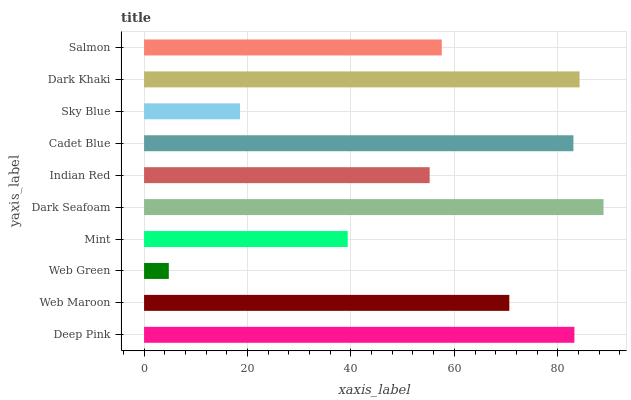Is Web Green the minimum?
Answer yes or no. Yes. Is Dark Seafoam the maximum?
Answer yes or no. Yes. Is Web Maroon the minimum?
Answer yes or no. No. Is Web Maroon the maximum?
Answer yes or no. No. Is Deep Pink greater than Web Maroon?
Answer yes or no. Yes. Is Web Maroon less than Deep Pink?
Answer yes or no. Yes. Is Web Maroon greater than Deep Pink?
Answer yes or no. No. Is Deep Pink less than Web Maroon?
Answer yes or no. No. Is Web Maroon the high median?
Answer yes or no. Yes. Is Salmon the low median?
Answer yes or no. Yes. Is Cadet Blue the high median?
Answer yes or no. No. Is Cadet Blue the low median?
Answer yes or no. No. 